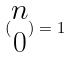Convert formula to latex. <formula><loc_0><loc_0><loc_500><loc_500>( \begin{matrix} n \\ 0 \end{matrix} ) = 1</formula> 